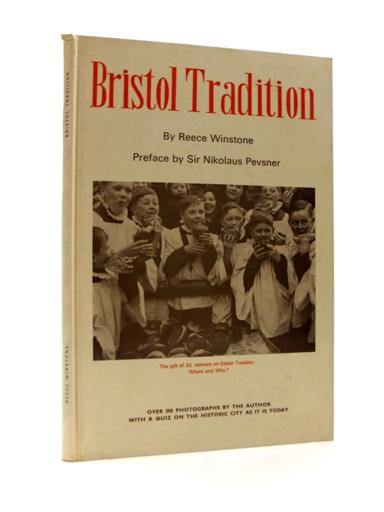What is the title of the book in the image? The title of the book depicted in the image is "Bristol Tradition," authored by Reece Winstone. This book appears to explore historical aspects of Bristol through its rich photographic content and historical narrative. 